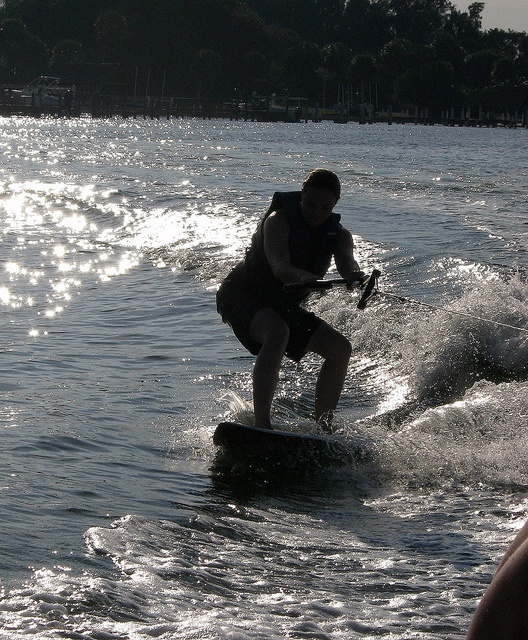Describe the objects in this image and their specific colors. I can see people in gray, black, darkgray, and lightgray tones and surfboard in gray, black, and purple tones in this image. 